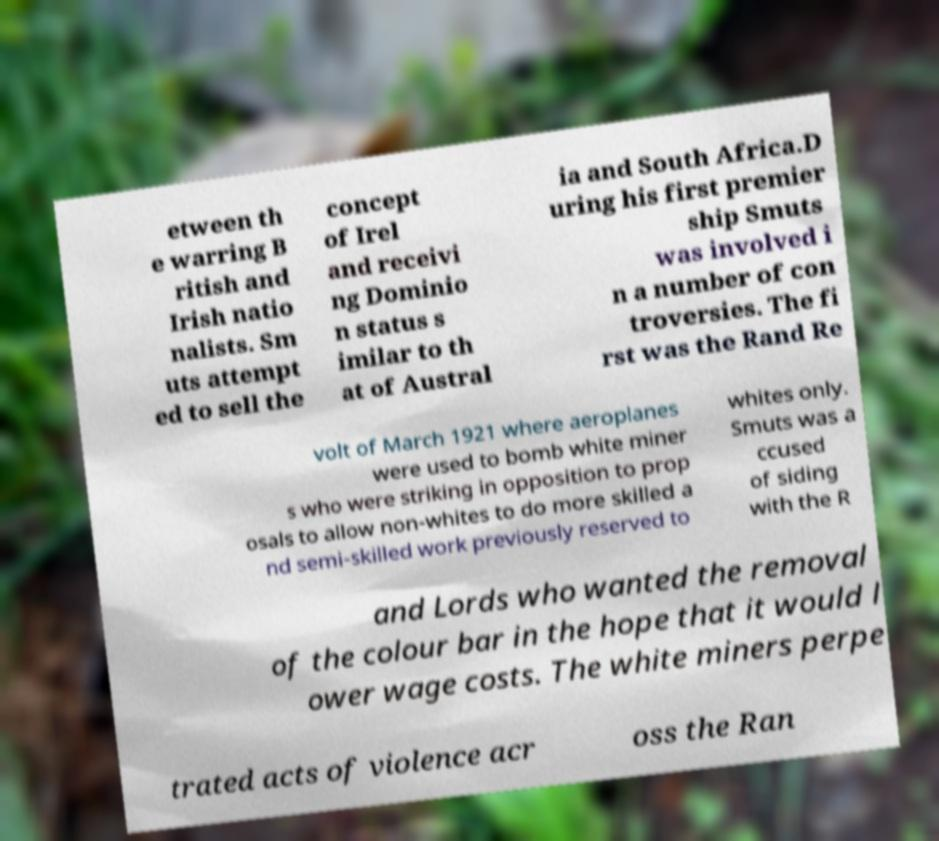Could you assist in decoding the text presented in this image and type it out clearly? etween th e warring B ritish and Irish natio nalists. Sm uts attempt ed to sell the concept of Irel and receivi ng Dominio n status s imilar to th at of Austral ia and South Africa.D uring his first premier ship Smuts was involved i n a number of con troversies. The fi rst was the Rand Re volt of March 1921 where aeroplanes were used to bomb white miner s who were striking in opposition to prop osals to allow non-whites to do more skilled a nd semi-skilled work previously reserved to whites only. Smuts was a ccused of siding with the R and Lords who wanted the removal of the colour bar in the hope that it would l ower wage costs. The white miners perpe trated acts of violence acr oss the Ran 